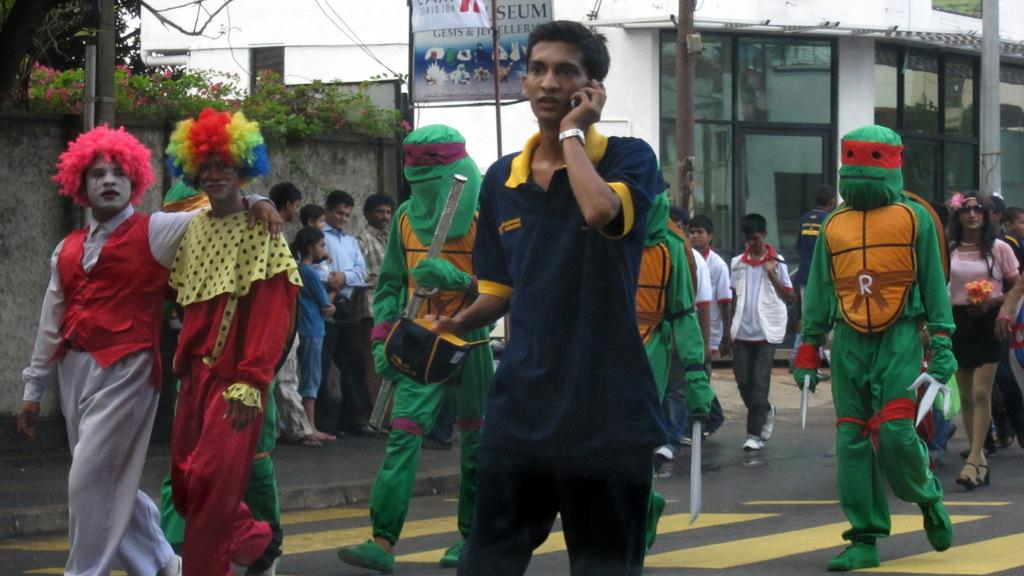How many people are in the image? There is a group of people in the image, but the exact number is not specified. What are some of the people in the image doing? Some people are standing, some are walking, and some are wearing costumes. What can be seen in the background of the image? There are buildings, trees, plants, and poles in the background of the image. What is the grade of the hill in the image? There is no hill present in the image; it features a group of people and various background elements. 